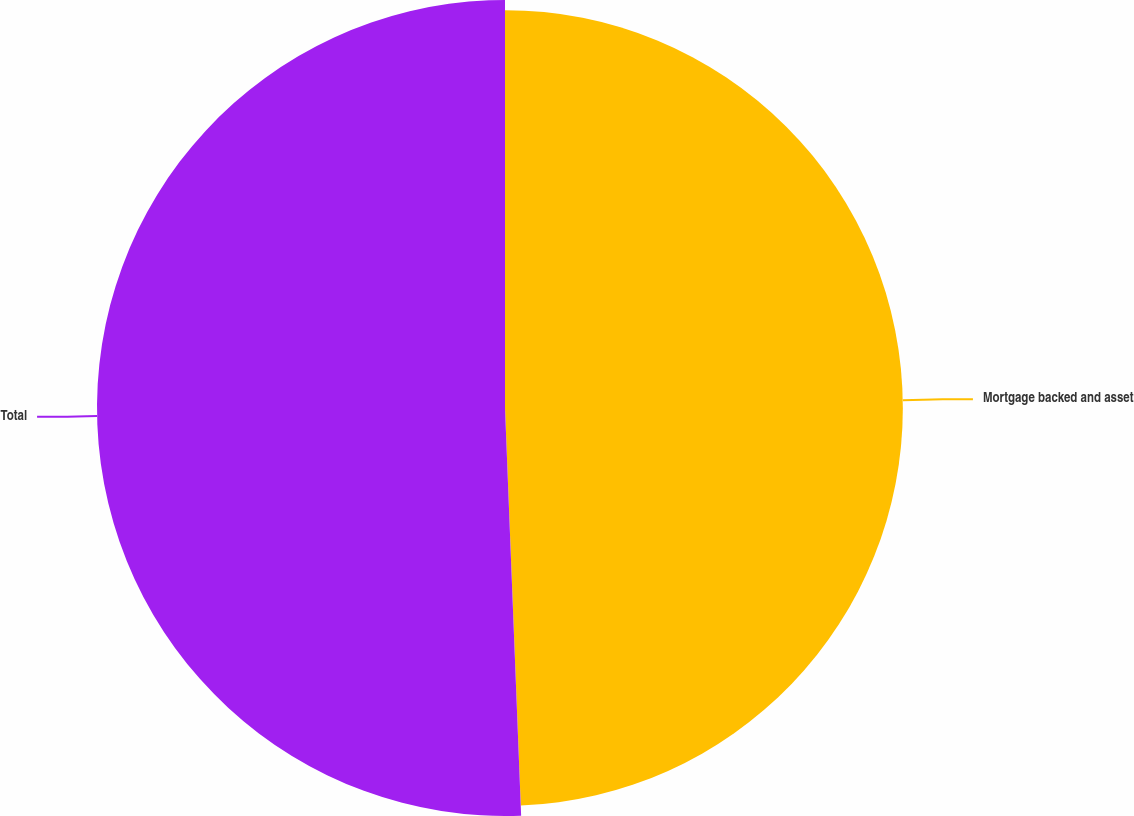<chart> <loc_0><loc_0><loc_500><loc_500><pie_chart><fcel>Mortgage backed and asset<fcel>Total<nl><fcel>49.37%<fcel>50.63%<nl></chart> 